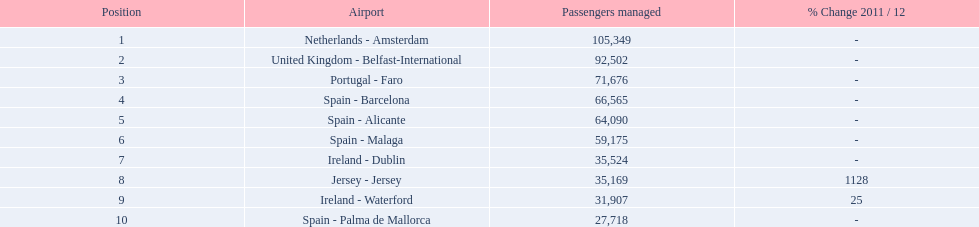What are all the passengers handled values for london southend airport? 105,349, 92,502, 71,676, 66,565, 64,090, 59,175, 35,524, 35,169, 31,907, 27,718. Which are 30,000 or less? 27,718. What airport is this for? Spain - Palma de Mallorca. 